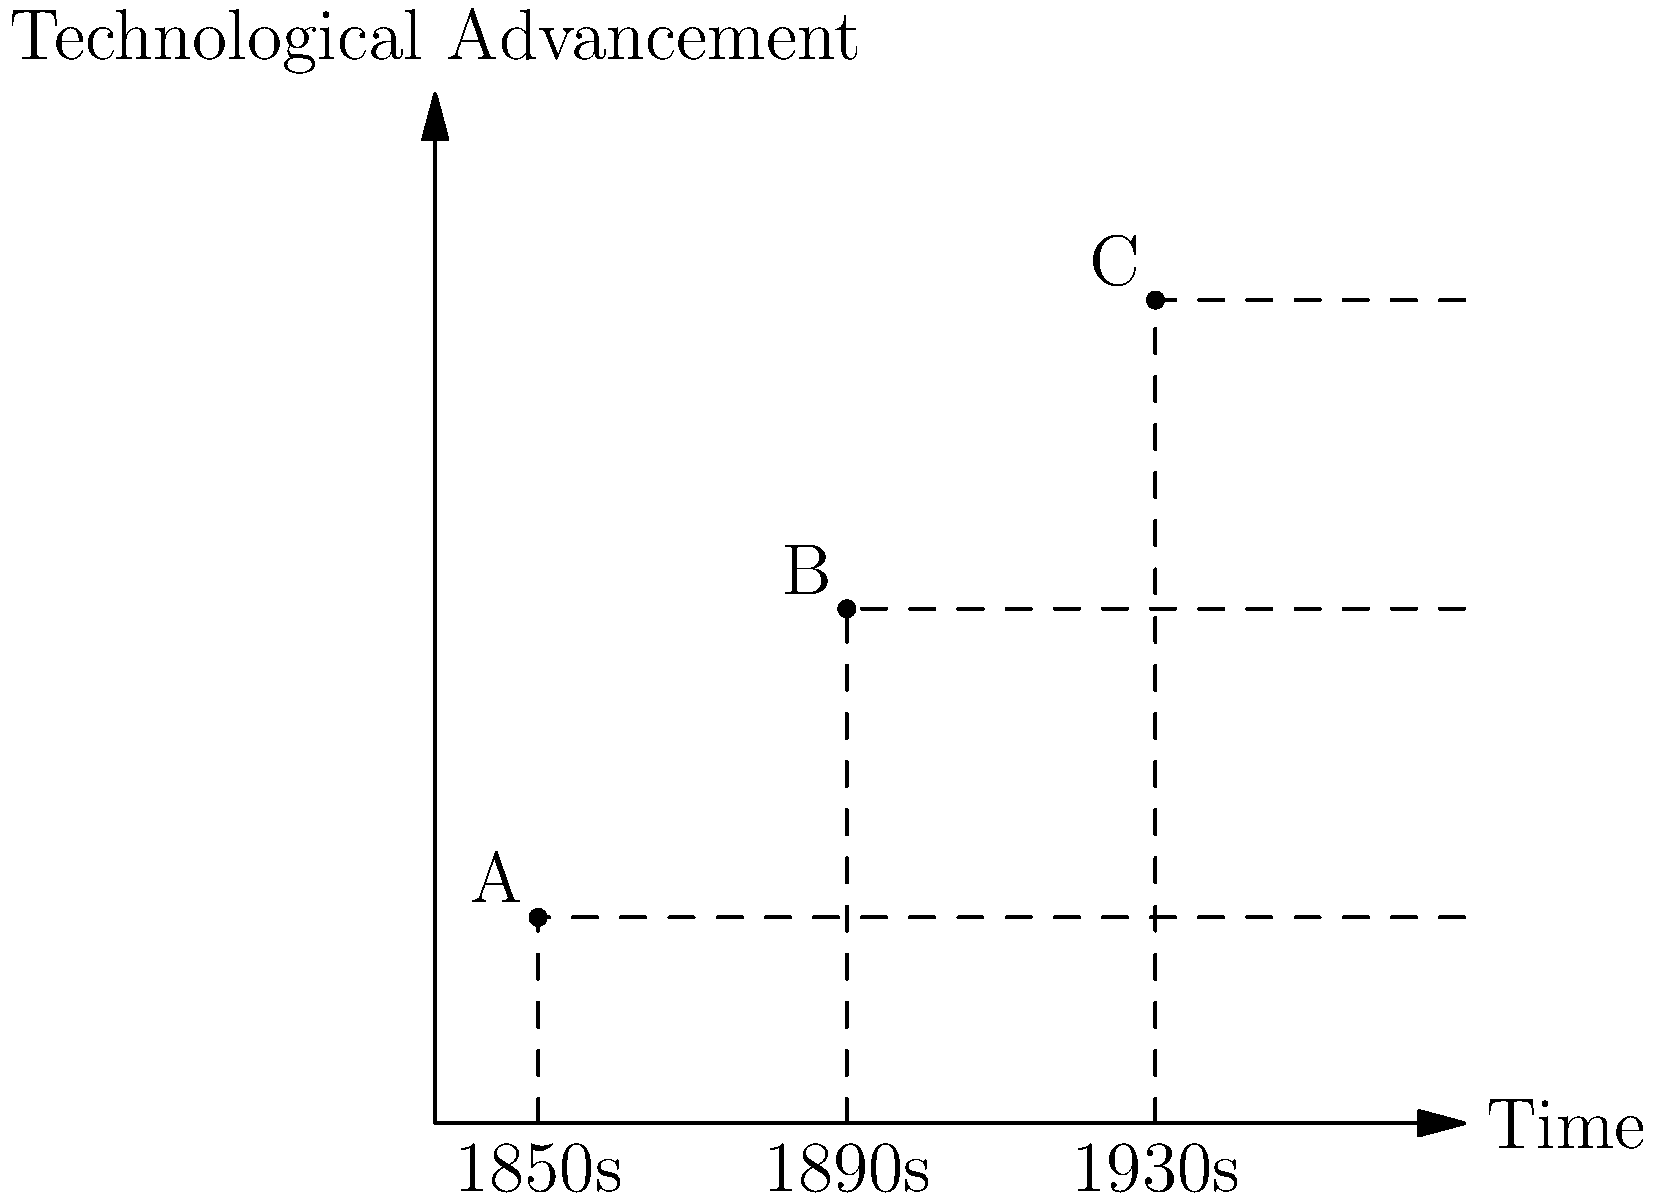Examine the schematic diagram representing the evolution of mining technology during Australia's gold rush era. Points A, B, and C correspond to specific mining equipment used in the 1850s, 1890s, and 1930s respectively. Which of these points likely represents the introduction of hydraulic mining techniques, and why would this technology be considered a significant advancement in gold extraction methods? To answer this question, we need to consider the timeline of technological advancements in gold mining during Australia's gold rush era:

1. 1850s (Point A): This period marks the beginning of the gold rush in Australia. Mining techniques were primarily manual, using simple tools like pans, cradles, and sluice boxes.

2. 1890s (Point B): This is the most likely period for the introduction of hydraulic mining techniques in Australia. Here's why:
   a) Hydraulic mining was first developed in California in the 1850s.
   b) It took time for this technology to spread and be adapted to Australian conditions.
   c) By the 1890s, many easily accessible surface gold deposits had been exhausted, necessitating more efficient extraction methods.
   d) The graph shows a significant technological jump from A to B, consistent with the impact of hydraulic mining.

3. 1930s (Point C): By this time, even more advanced techniques like dredging and hard rock mining were becoming common. The technological advancement from B to C is less dramatic, suggesting refinements rather than revolutionary changes.

Hydraulic mining was considered a significant advancement because:
1. It allowed for the processing of large volumes of auriferous (gold-bearing) soil and gravel.
2. It could reach gold deposits that were inaccessible through traditional placer mining methods.
3. It greatly increased the efficiency of gold extraction, allowing for the profitable mining of lower-grade deposits.
4. It reduced the need for manual labor, although it also had significant environmental impacts.
Answer: Point B (1890s), due to its timing and the significant technological leap it represents. 